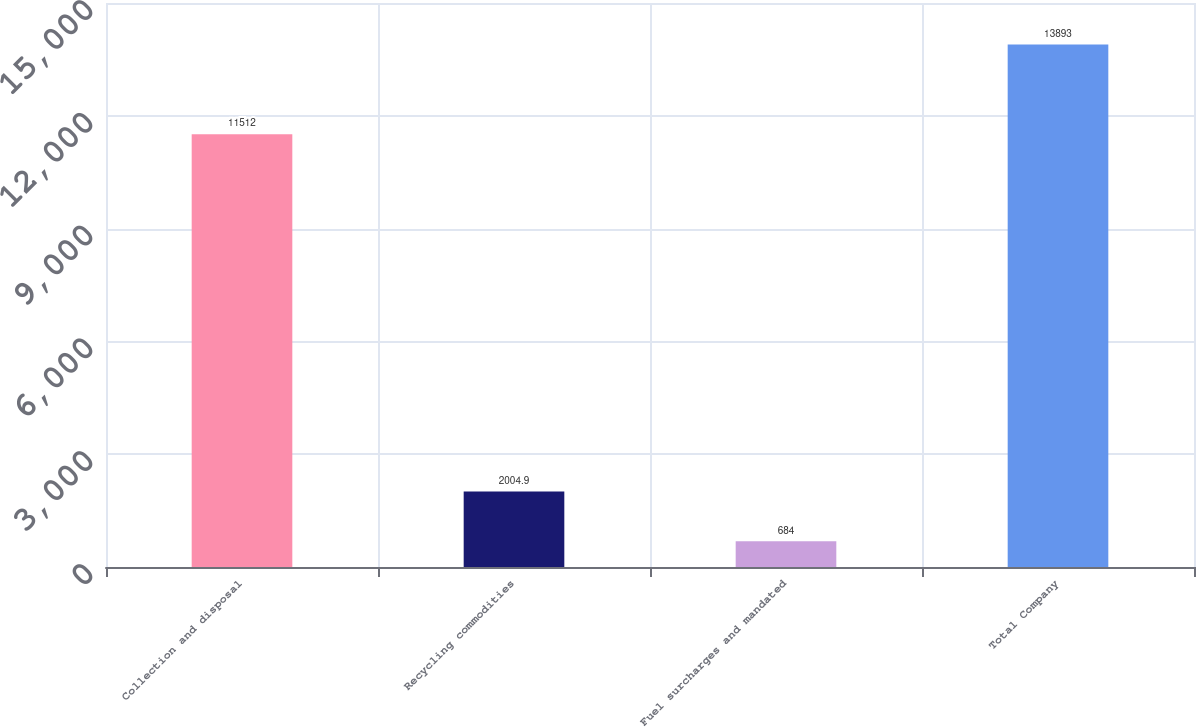Convert chart to OTSL. <chart><loc_0><loc_0><loc_500><loc_500><bar_chart><fcel>Collection and disposal<fcel>Recycling commodities<fcel>Fuel surcharges and mandated<fcel>Total Company<nl><fcel>11512<fcel>2004.9<fcel>684<fcel>13893<nl></chart> 